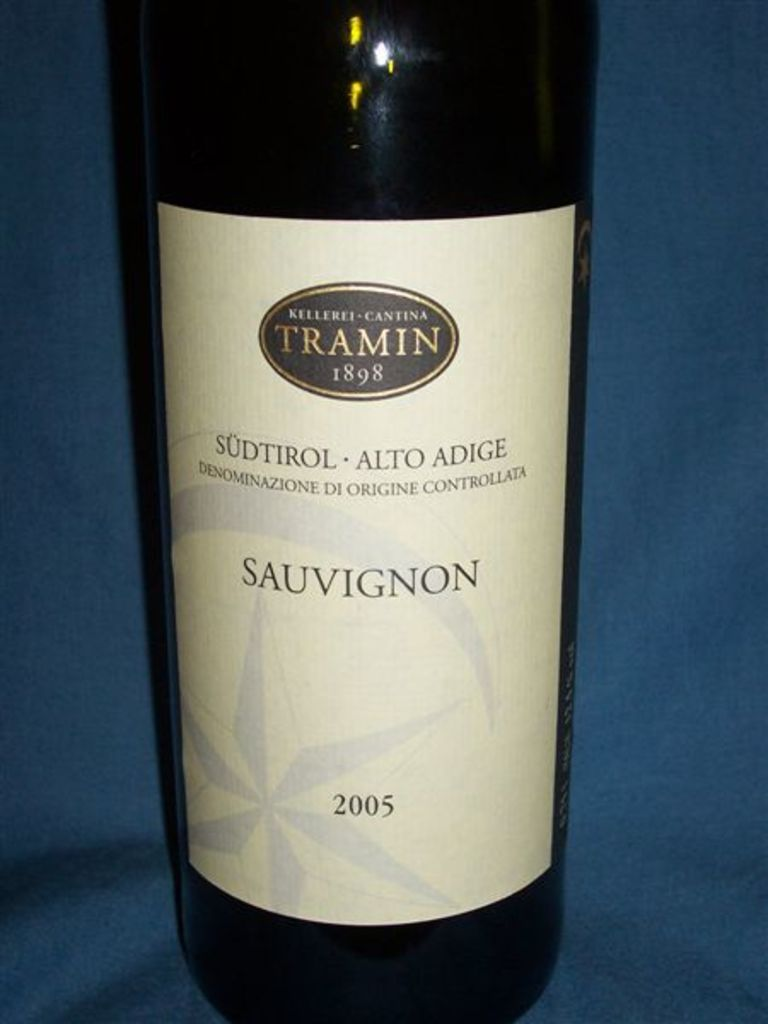Can you tell me more about the wine region mentioned on the bottle? Certainly! Südtirol, also known as Alto Adige, is a renowned wine-producing area in northern Italy. It's uniquely positioned in the Alps, which provides an ideal climate for viticulture. The region is known for its diverse grape varieties, including the Sauvignon depicted in the image. The cool climate contributes to the crisp acidity and aromatic intensity of the wines here, making them highly sought after for their quality and distinctive profiles. 